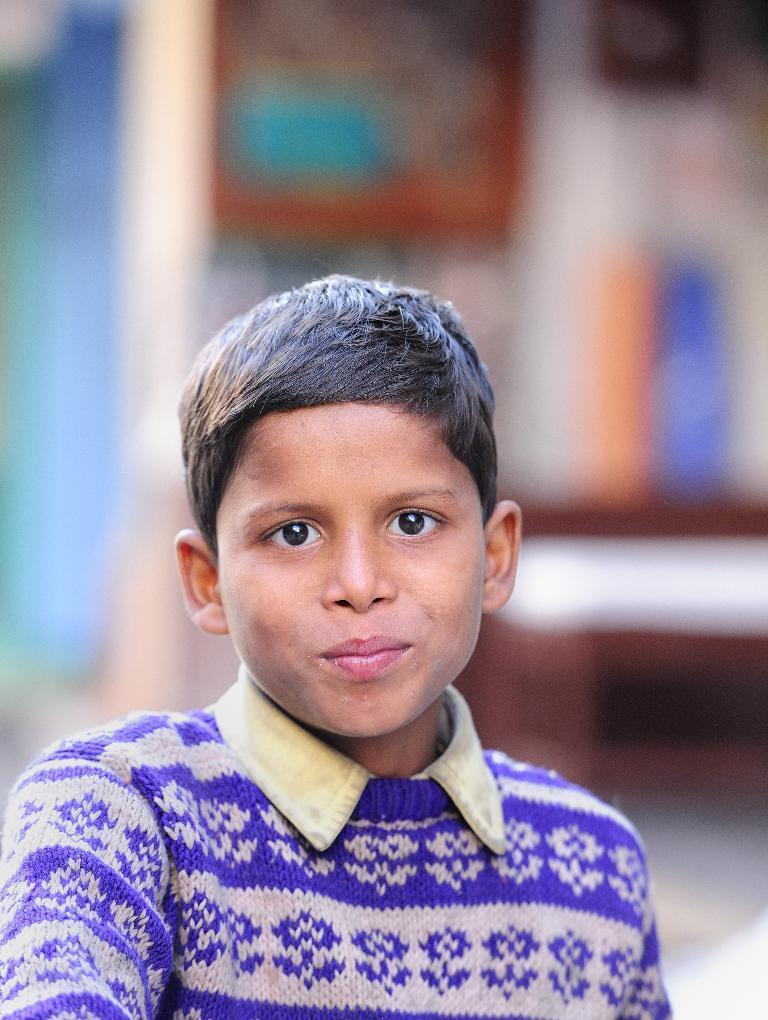How would you summarize this image in a sentence or two? There is a boy wore t shirt. In the background it is blur. 